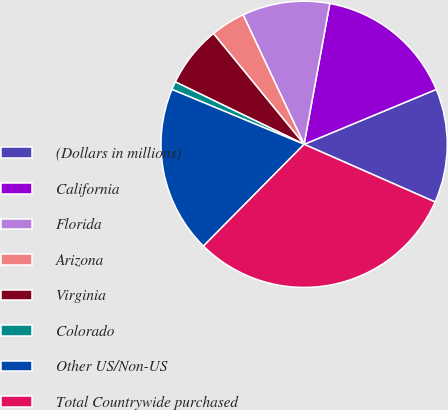<chart> <loc_0><loc_0><loc_500><loc_500><pie_chart><fcel>(Dollars in millions)<fcel>California<fcel>Florida<fcel>Arizona<fcel>Virginia<fcel>Colorado<fcel>Other US/Non-US<fcel>Total Countrywide purchased<nl><fcel>12.87%<fcel>15.86%<fcel>9.88%<fcel>3.91%<fcel>6.9%<fcel>0.92%<fcel>18.85%<fcel>30.81%<nl></chart> 